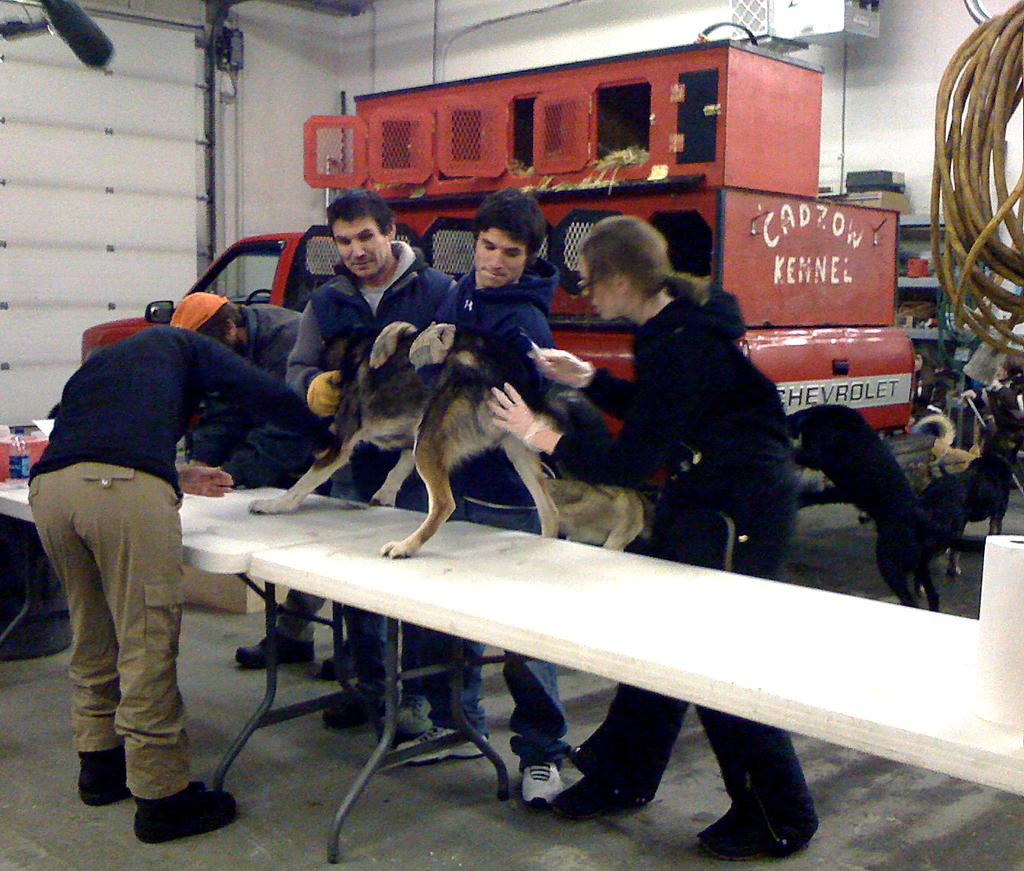Who or what is being held by the people in the image? The people are holding a dog in the image. Where is the dog being held? The dog is standing on a table. Are there any other dogs in the image? Yes, there are dogs standing on the floor. What type of peace symbol can be seen in the image? There is no peace symbol present in the image. What kind of pear is being used as a pet in the image? There is no pear being used as a pet in the image; the people are holding a dog. 